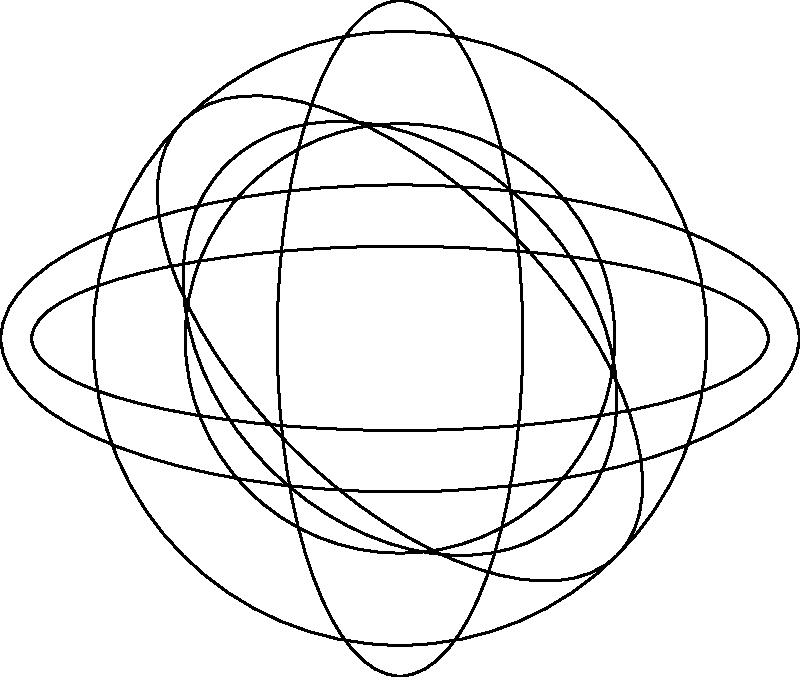In designing a multi-tool knife with various tool shapes arranged radially, you've plotted the tool outlines using polar coordinates. The base circle has a radius $r$, and each tool shape is a modified circle scaled and rotated at 45° intervals. If the area of the largest tool (at 0°) is $A$, what is the approximate area of the tool at 135°, expressed as a fraction of $A$? To solve this problem, let's follow these steps:

1) The base circle has a radius $r$, so its area is $A = \pi r^2$.

2) Each tool shape is a modified circle, scaled differently in the radial and tangential directions.

3) The tool at 0° is a full circle with radius $r$, so its area is $A = \pi r^2$.

4) The tool at 135° appears to be scaled to about 0.7 of the original circle in both directions.

5) When a shape is scaled by a factor $k$ in both dimensions, its area is scaled by a factor of $k^2$.

6) For the tool at 135°, the scaling factor $k = 0.7$, so the area scaling factor is $k^2 = 0.7^2 = 0.49$.

7) Therefore, the area of the tool at 135° is approximately $0.49A$.

8) This can be expressed as a fraction: $\frac{49}{100}A$ or simplified to $\frac{49A}{100}$.
Answer: $\frac{49}{100}A$ 